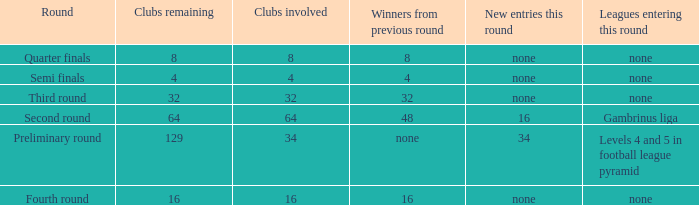Name the new entries this round for third round None. 